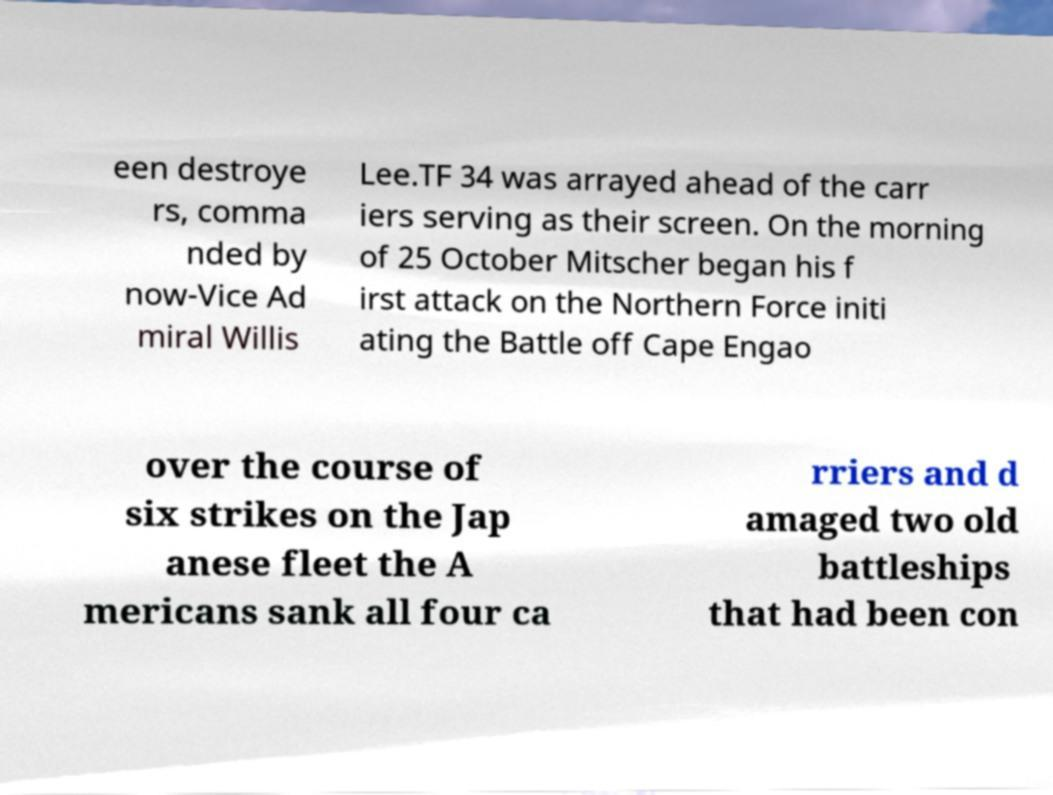Could you assist in decoding the text presented in this image and type it out clearly? een destroye rs, comma nded by now-Vice Ad miral Willis Lee.TF 34 was arrayed ahead of the carr iers serving as their screen. On the morning of 25 October Mitscher began his f irst attack on the Northern Force initi ating the Battle off Cape Engao over the course of six strikes on the Jap anese fleet the A mericans sank all four ca rriers and d amaged two old battleships that had been con 